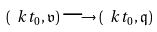<formula> <loc_0><loc_0><loc_500><loc_500>( \ k t _ { 0 } , \mathfrak { v } ) \longrightarrow ( \ k t _ { 0 } , \mathfrak { q } )</formula> 